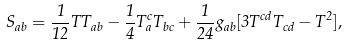Convert formula to latex. <formula><loc_0><loc_0><loc_500><loc_500>S _ { a b } = \frac { 1 } { 1 2 } T T _ { a b } - \frac { 1 } { 4 } T _ { a } ^ { c } T _ { b c } + \frac { 1 } { 2 4 } g _ { a b } [ 3 T ^ { c d } T _ { c d } - T ^ { 2 } ] ,</formula> 